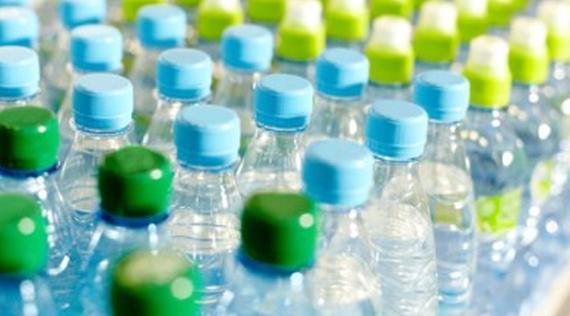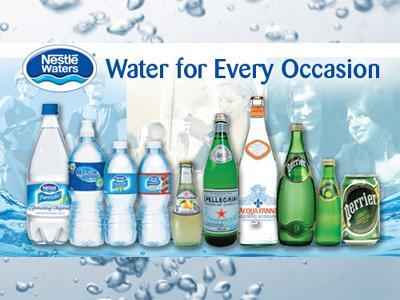The first image is the image on the left, the second image is the image on the right. For the images shown, is this caption "There is exactly one water bottle in the image on the left." true? Answer yes or no. No. The first image is the image on the left, the second image is the image on the right. Analyze the images presented: Is the assertion "An image shows exactly one water bottle." valid? Answer yes or no. No. 